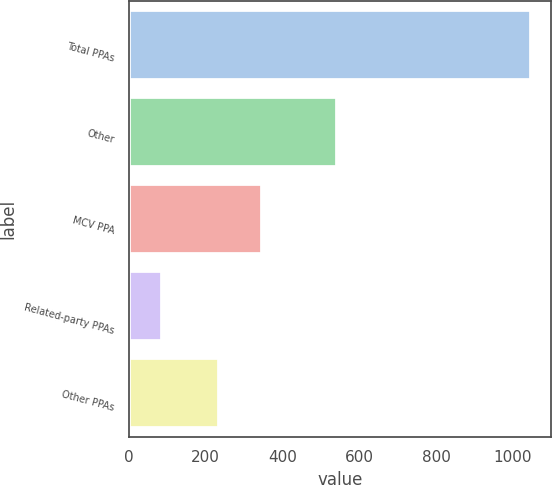Convert chart to OTSL. <chart><loc_0><loc_0><loc_500><loc_500><bar_chart><fcel>Total PPAs<fcel>Other<fcel>MCV PPA<fcel>Related-party PPAs<fcel>Other PPAs<nl><fcel>1048<fcel>541<fcel>348<fcel>87<fcel>235<nl></chart> 